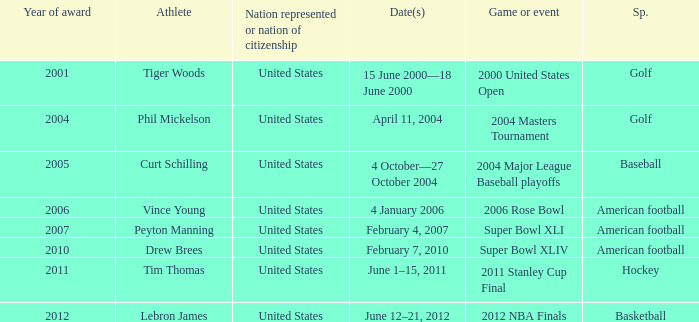In 2011 which sport had the year award? Hockey. 